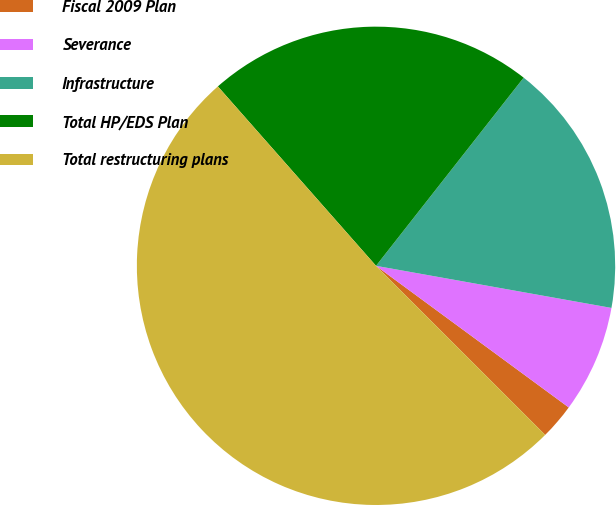Convert chart. <chart><loc_0><loc_0><loc_500><loc_500><pie_chart><fcel>Fiscal 2009 Plan<fcel>Severance<fcel>Infrastructure<fcel>Total HP/EDS Plan<fcel>Total restructuring plans<nl><fcel>2.41%<fcel>7.27%<fcel>17.23%<fcel>22.09%<fcel>51.01%<nl></chart> 